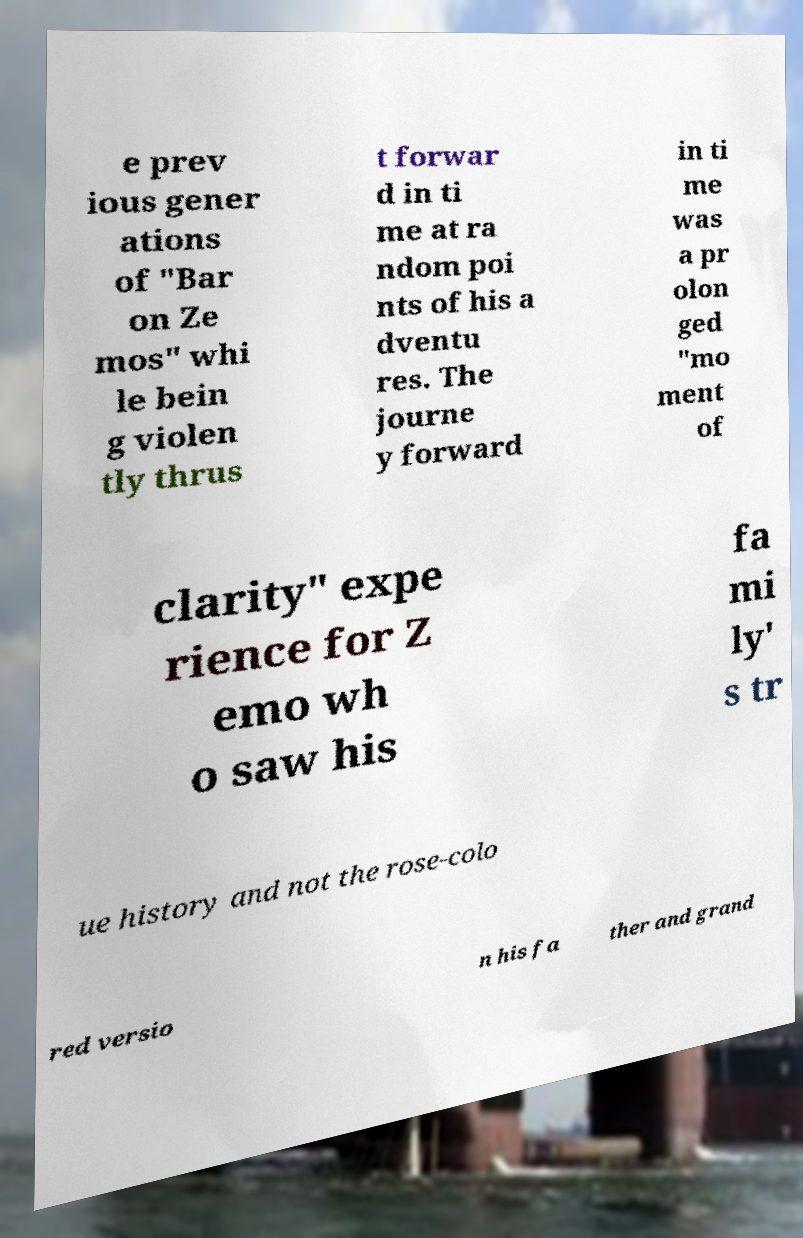For documentation purposes, I need the text within this image transcribed. Could you provide that? e prev ious gener ations of "Bar on Ze mos" whi le bein g violen tly thrus t forwar d in ti me at ra ndom poi nts of his a dventu res. The journe y forward in ti me was a pr olon ged "mo ment of clarity" expe rience for Z emo wh o saw his fa mi ly' s tr ue history and not the rose-colo red versio n his fa ther and grand 